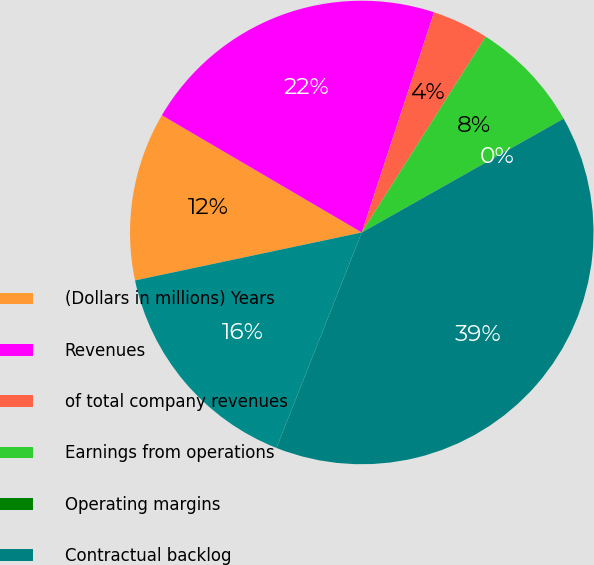Convert chart to OTSL. <chart><loc_0><loc_0><loc_500><loc_500><pie_chart><fcel>(Dollars in millions) Years<fcel>Revenues<fcel>of total company revenues<fcel>Earnings from operations<fcel>Operating margins<fcel>Contractual backlog<fcel>Unobligated backlog<nl><fcel>11.76%<fcel>21.61%<fcel>3.93%<fcel>7.84%<fcel>0.01%<fcel>39.17%<fcel>15.68%<nl></chart> 